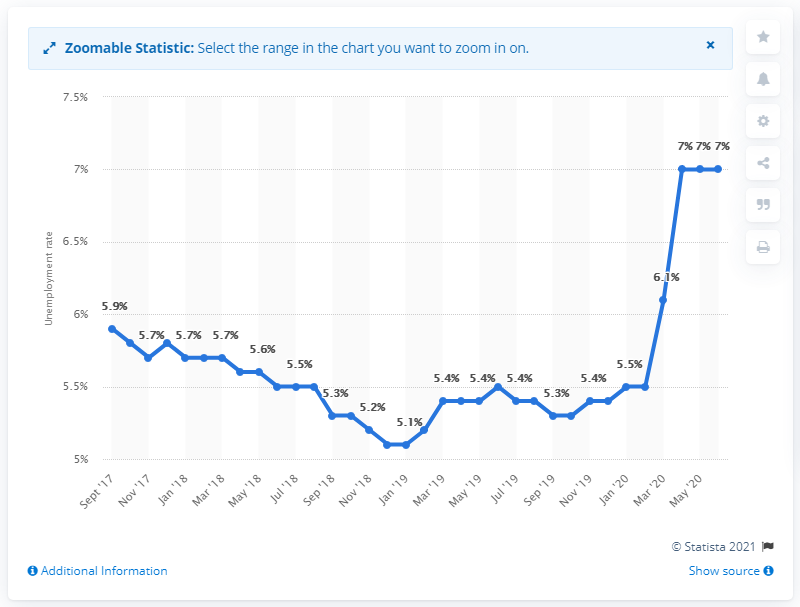Can you analyze the trend in the unemployment rate depicted in this chart? Certainly! The chart shows a downward trend in Luxembourg's unemployment rate from September 2017 until around March 2020, where it fluctuated between 5.2% and 5.9%. However, there's a dramatic spike to 7% in the final data point, indicating a significant increase at that time. 